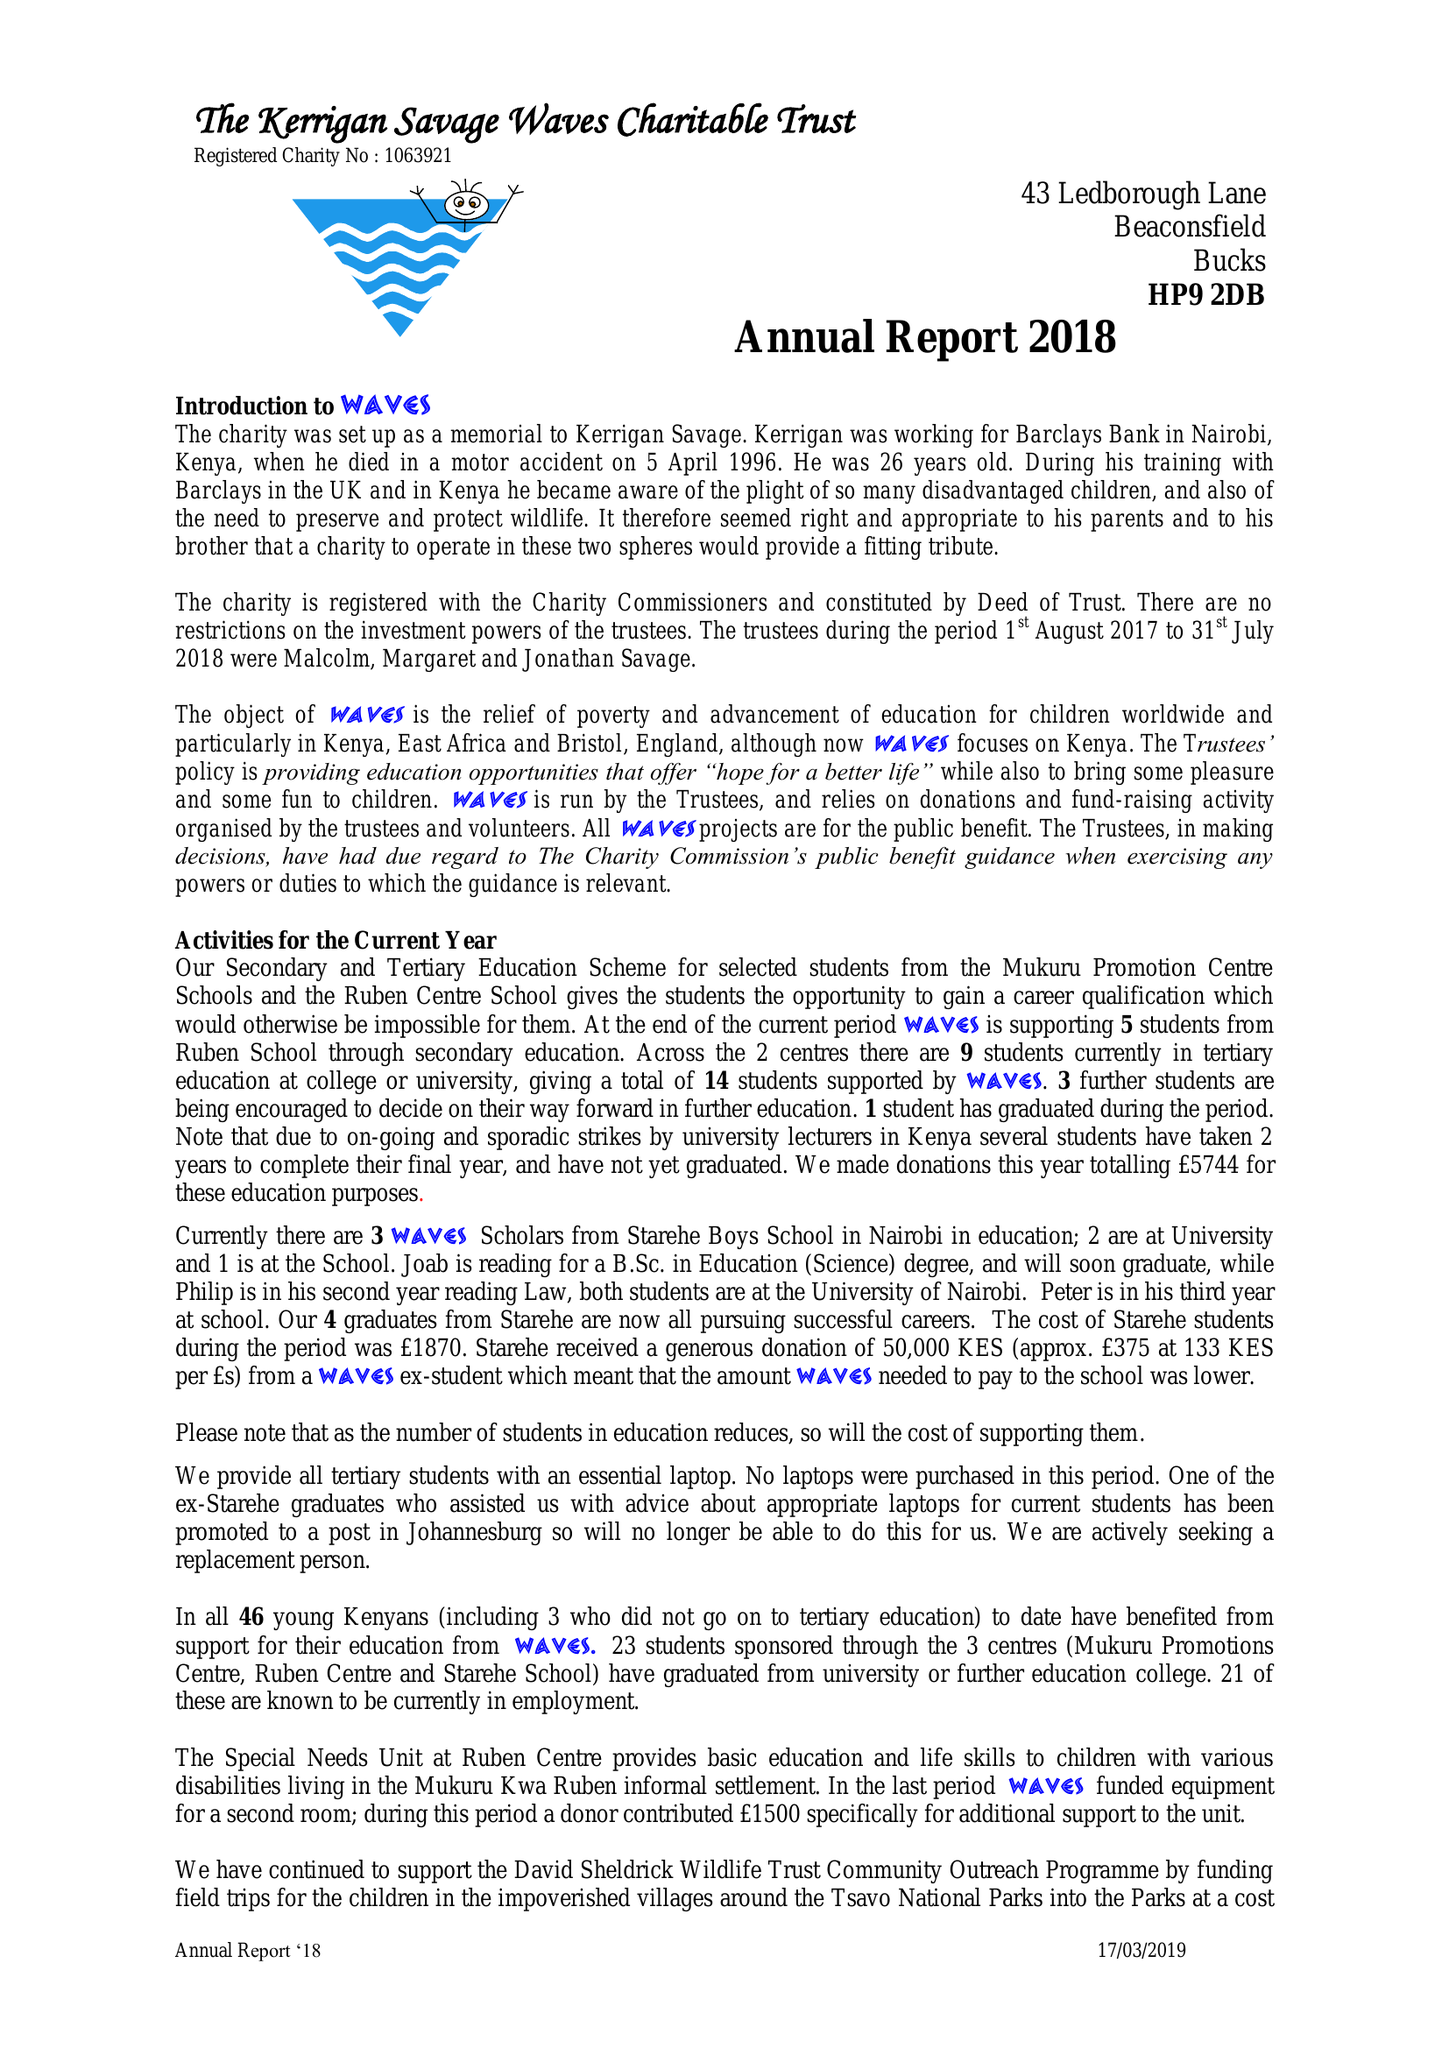What is the value for the report_date?
Answer the question using a single word or phrase. 2018-07-31 